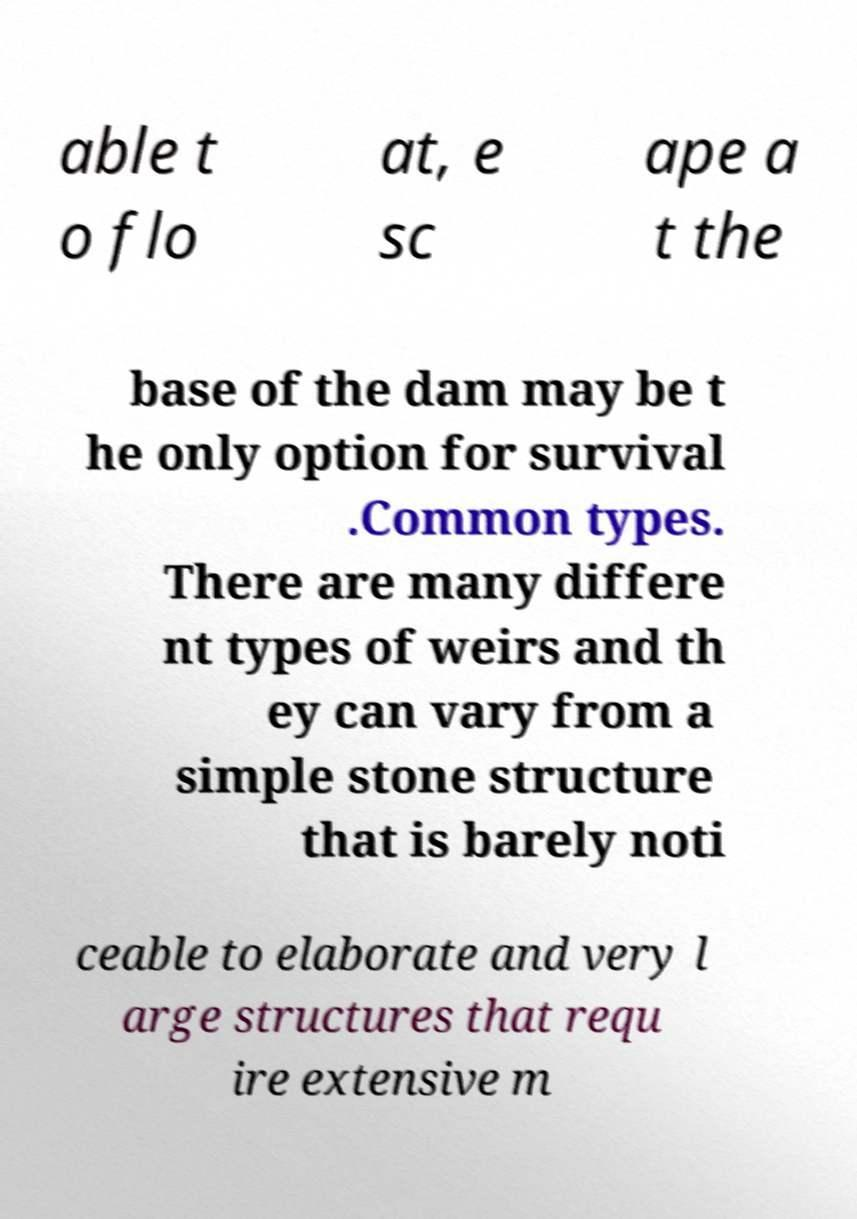Please identify and transcribe the text found in this image. able t o flo at, e sc ape a t the base of the dam may be t he only option for survival .Common types. There are many differe nt types of weirs and th ey can vary from a simple stone structure that is barely noti ceable to elaborate and very l arge structures that requ ire extensive m 